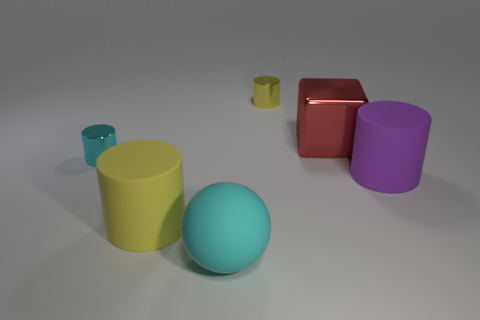Subtract all small cyan shiny cylinders. How many cylinders are left? 3 Add 3 large purple objects. How many objects exist? 9 Subtract all spheres. How many objects are left? 5 Subtract all metallic objects. Subtract all big gray objects. How many objects are left? 3 Add 4 spheres. How many spheres are left? 5 Add 1 tiny purple objects. How many tiny purple objects exist? 1 Subtract 0 purple cubes. How many objects are left? 6 